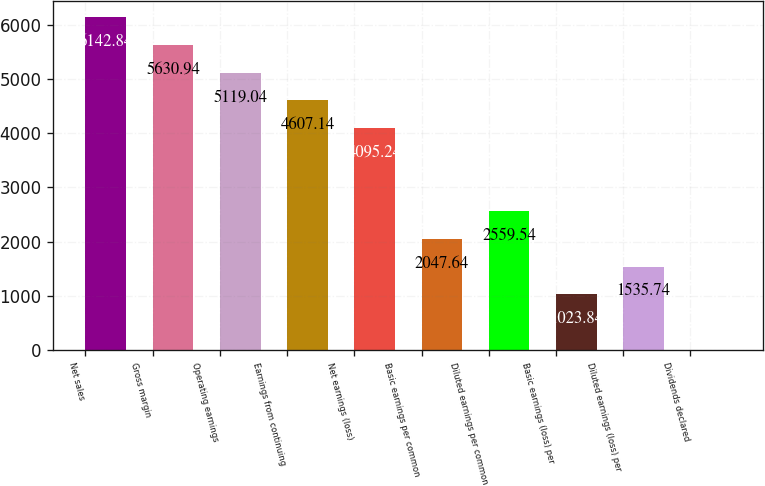<chart> <loc_0><loc_0><loc_500><loc_500><bar_chart><fcel>Net sales<fcel>Gross margin<fcel>Operating earnings<fcel>Earnings from continuing<fcel>Net earnings (loss)<fcel>Basic earnings per common<fcel>Diluted earnings per common<fcel>Basic earnings (loss) per<fcel>Diluted earnings (loss) per<fcel>Dividends declared<nl><fcel>6142.84<fcel>5630.94<fcel>5119.04<fcel>4607.14<fcel>4095.24<fcel>2047.64<fcel>2559.54<fcel>1023.84<fcel>1535.74<fcel>0.04<nl></chart> 